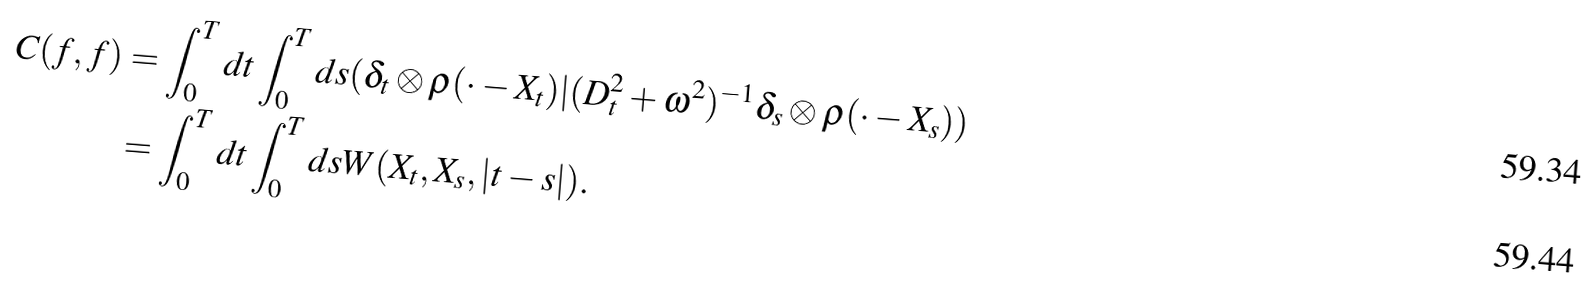Convert formula to latex. <formula><loc_0><loc_0><loc_500><loc_500>C ( f , f ) & = \int _ { 0 } ^ { T } d t \int _ { 0 } ^ { T } d s ( \delta _ { t } \otimes \rho ( \cdot - X _ { t } ) | ( D _ { t } ^ { 2 } + \omega ^ { 2 } ) ^ { - 1 } \delta _ { s } \otimes \rho ( \cdot - X _ { s } ) ) \\ & = \int _ { 0 } ^ { T } d t \int _ { 0 } ^ { T } d s W ( X _ { t } , X _ { s } , | t - s | ) .</formula> 